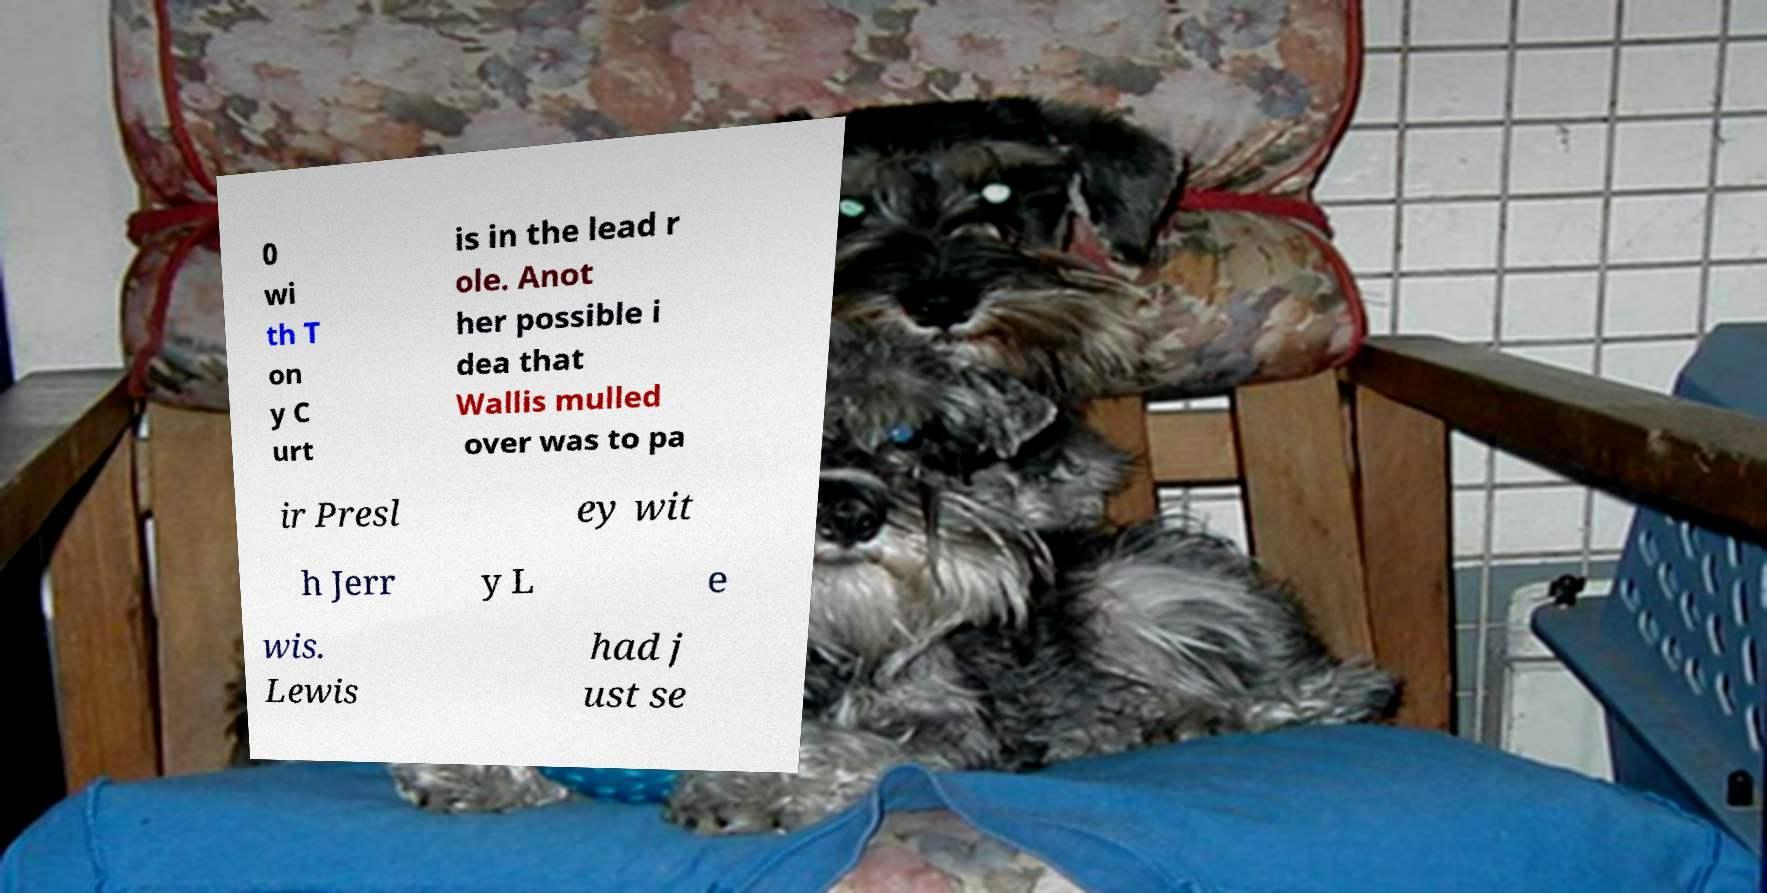Can you read and provide the text displayed in the image?This photo seems to have some interesting text. Can you extract and type it out for me? 0 wi th T on y C urt is in the lead r ole. Anot her possible i dea that Wallis mulled over was to pa ir Presl ey wit h Jerr y L e wis. Lewis had j ust se 